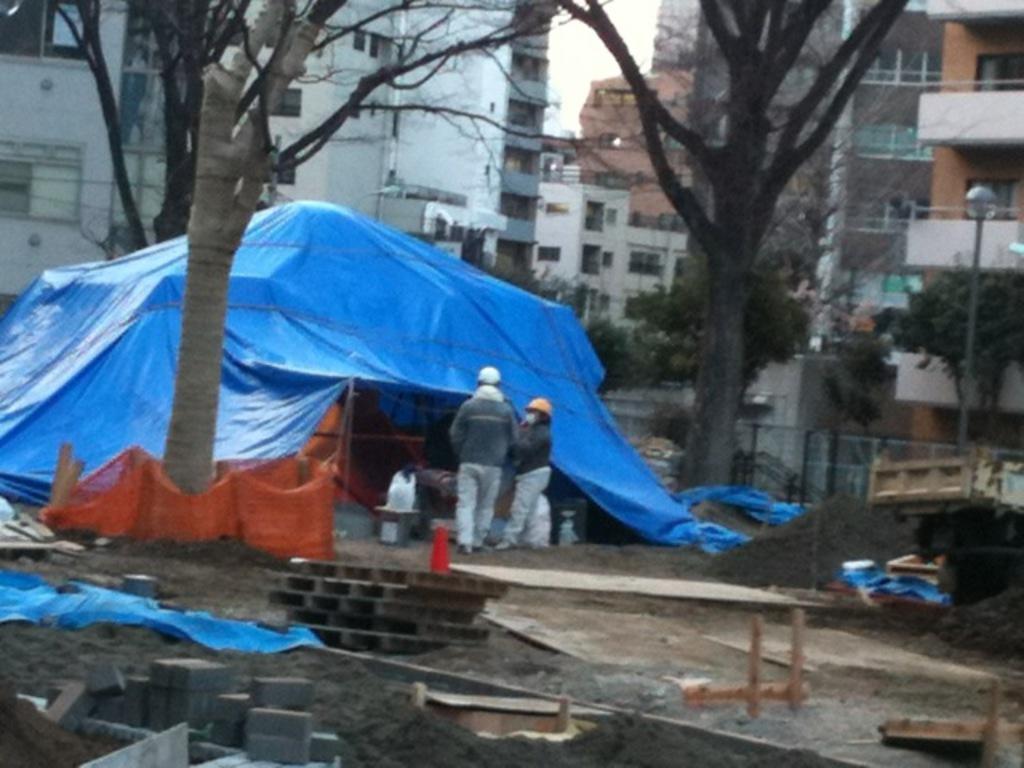How would you summarize this image in a sentence or two? In the center of the image, we can see a tent and some people and are wearing helmets and there are bricks, asbestos, a table, sand and some other objects and there are clothes. In the background, we can see a fence, trees and buildings and there is a pole. 